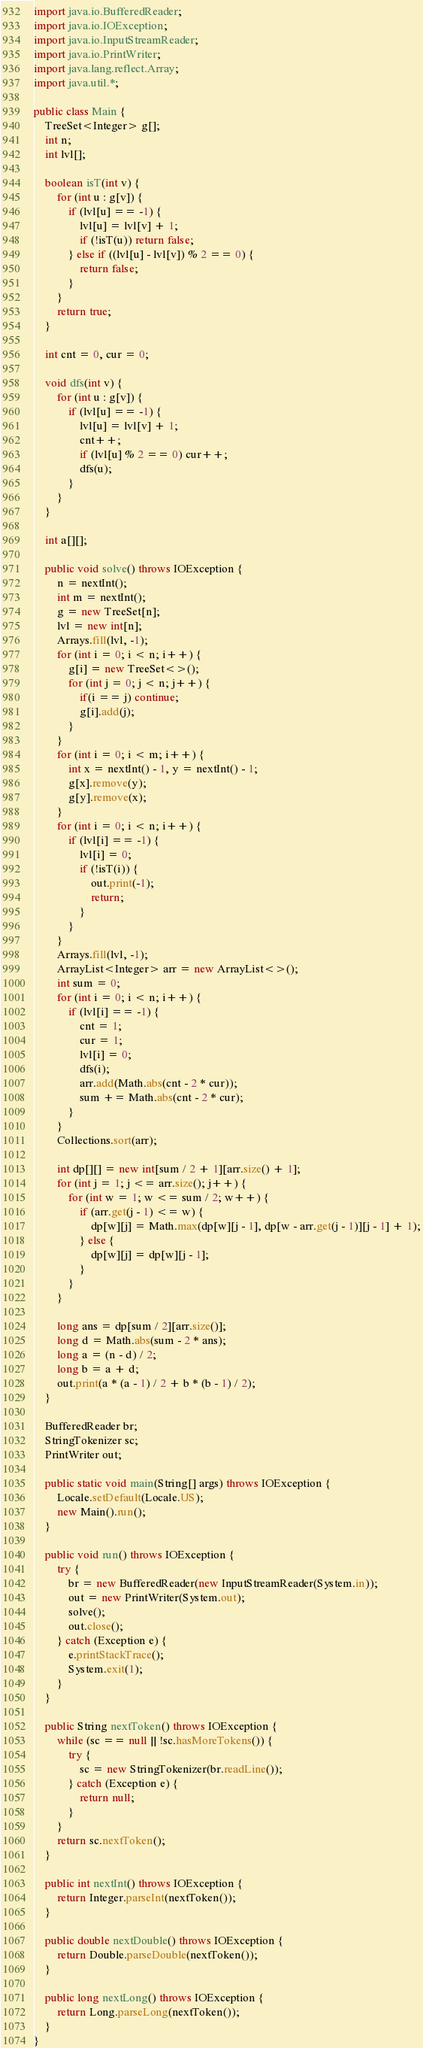<code> <loc_0><loc_0><loc_500><loc_500><_Java_>import java.io.BufferedReader;
import java.io.IOException;
import java.io.InputStreamReader;
import java.io.PrintWriter;
import java.lang.reflect.Array;
import java.util.*;

public class Main {
    TreeSet<Integer> g[];
    int n;
    int lvl[];

    boolean isT(int v) {
        for (int u : g[v]) {
            if (lvl[u] == -1) {
                lvl[u] = lvl[v] + 1;
                if (!isT(u)) return false;
            } else if ((lvl[u] - lvl[v]) % 2 == 0) {
                return false;
            }
        }
        return true;
    }

    int cnt = 0, cur = 0;

    void dfs(int v) {
        for (int u : g[v]) {
            if (lvl[u] == -1) {
                lvl[u] = lvl[v] + 1;
                cnt++;
                if (lvl[u] % 2 == 0) cur++;
                dfs(u);
            }
        }
    }

    int a[][];

    public void solve() throws IOException {
        n = nextInt();
        int m = nextInt();
        g = new TreeSet[n];
        lvl = new int[n];
        Arrays.fill(lvl, -1);
        for (int i = 0; i < n; i++) {
            g[i] = new TreeSet<>();
            for (int j = 0; j < n; j++) {
                if(i == j) continue;
                g[i].add(j);
            }
        }
        for (int i = 0; i < m; i++) {
            int x = nextInt() - 1, y = nextInt() - 1;
            g[x].remove(y);
            g[y].remove(x);
        }
        for (int i = 0; i < n; i++) {
            if (lvl[i] == -1) {
                lvl[i] = 0;
                if (!isT(i)) {
                    out.print(-1);
                    return;
                }
            }
        }
        Arrays.fill(lvl, -1);
        ArrayList<Integer> arr = new ArrayList<>();
        int sum = 0;
        for (int i = 0; i < n; i++) {
            if (lvl[i] == -1) {
                cnt = 1;
                cur = 1;
                lvl[i] = 0;
                dfs(i);
                arr.add(Math.abs(cnt - 2 * cur));
                sum += Math.abs(cnt - 2 * cur);
            }
        }
        Collections.sort(arr);

        int dp[][] = new int[sum / 2 + 1][arr.size() + 1];
        for (int j = 1; j <= arr.size(); j++) {
            for (int w = 1; w <= sum / 2; w++) {
                if (arr.get(j - 1) <= w) {
                    dp[w][j] = Math.max(dp[w][j - 1], dp[w - arr.get(j - 1)][j - 1] + 1);
                } else {
                    dp[w][j] = dp[w][j - 1];
                }
            }
        }

        long ans = dp[sum / 2][arr.size()];
        long d = Math.abs(sum - 2 * ans);
        long a = (n - d) / 2;
        long b = a + d;
        out.print(a * (a - 1) / 2 + b * (b - 1) / 2);
    }

    BufferedReader br;
    StringTokenizer sc;
    PrintWriter out;

    public static void main(String[] args) throws IOException {
        Locale.setDefault(Locale.US);
        new Main().run();
    }

    public void run() throws IOException {
        try {
            br = new BufferedReader(new InputStreamReader(System.in));
            out = new PrintWriter(System.out);
            solve();
            out.close();
        } catch (Exception e) {
            e.printStackTrace();
            System.exit(1);
        }
    }

    public String nextToken() throws IOException {
        while (sc == null || !sc.hasMoreTokens()) {
            try {
                sc = new StringTokenizer(br.readLine());
            } catch (Exception e) {
                return null;
            }
        }
        return sc.nextToken();
    }

    public int nextInt() throws IOException {
        return Integer.parseInt(nextToken());
    }

    public double nextDouble() throws IOException {
        return Double.parseDouble(nextToken());
    }

    public long nextLong() throws IOException {
        return Long.parseLong(nextToken());
    }
}
</code> 